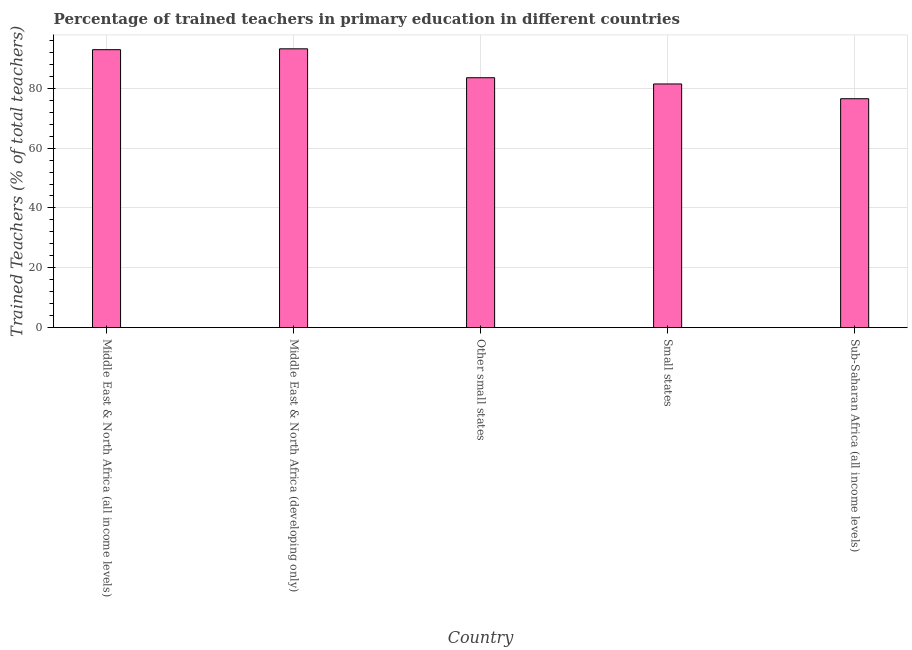Does the graph contain any zero values?
Your answer should be very brief. No. Does the graph contain grids?
Offer a very short reply. Yes. What is the title of the graph?
Make the answer very short. Percentage of trained teachers in primary education in different countries. What is the label or title of the X-axis?
Give a very brief answer. Country. What is the label or title of the Y-axis?
Provide a succinct answer. Trained Teachers (% of total teachers). What is the percentage of trained teachers in Middle East & North Africa (developing only)?
Your answer should be very brief. 93.18. Across all countries, what is the maximum percentage of trained teachers?
Provide a short and direct response. 93.18. Across all countries, what is the minimum percentage of trained teachers?
Your answer should be compact. 76.5. In which country was the percentage of trained teachers maximum?
Provide a short and direct response. Middle East & North Africa (developing only). In which country was the percentage of trained teachers minimum?
Provide a succinct answer. Sub-Saharan Africa (all income levels). What is the sum of the percentage of trained teachers?
Ensure brevity in your answer.  427.52. What is the difference between the percentage of trained teachers in Other small states and Sub-Saharan Africa (all income levels)?
Give a very brief answer. 7.02. What is the average percentage of trained teachers per country?
Keep it short and to the point. 85.5. What is the median percentage of trained teachers?
Provide a succinct answer. 83.52. What is the ratio of the percentage of trained teachers in Middle East & North Africa (all income levels) to that in Small states?
Offer a very short reply. 1.14. Is the percentage of trained teachers in Other small states less than that in Small states?
Offer a very short reply. No. Is the difference between the percentage of trained teachers in Other small states and Sub-Saharan Africa (all income levels) greater than the difference between any two countries?
Keep it short and to the point. No. What is the difference between the highest and the second highest percentage of trained teachers?
Your response must be concise. 0.29. What is the difference between the highest and the lowest percentage of trained teachers?
Give a very brief answer. 16.68. In how many countries, is the percentage of trained teachers greater than the average percentage of trained teachers taken over all countries?
Your answer should be very brief. 2. How many bars are there?
Offer a very short reply. 5. Are all the bars in the graph horizontal?
Ensure brevity in your answer.  No. What is the difference between two consecutive major ticks on the Y-axis?
Your response must be concise. 20. What is the Trained Teachers (% of total teachers) of Middle East & North Africa (all income levels)?
Your answer should be compact. 92.89. What is the Trained Teachers (% of total teachers) in Middle East & North Africa (developing only)?
Your answer should be very brief. 93.18. What is the Trained Teachers (% of total teachers) in Other small states?
Give a very brief answer. 83.52. What is the Trained Teachers (% of total teachers) in Small states?
Provide a succinct answer. 81.43. What is the Trained Teachers (% of total teachers) of Sub-Saharan Africa (all income levels)?
Offer a very short reply. 76.5. What is the difference between the Trained Teachers (% of total teachers) in Middle East & North Africa (all income levels) and Middle East & North Africa (developing only)?
Your answer should be compact. -0.29. What is the difference between the Trained Teachers (% of total teachers) in Middle East & North Africa (all income levels) and Other small states?
Offer a terse response. 9.38. What is the difference between the Trained Teachers (% of total teachers) in Middle East & North Africa (all income levels) and Small states?
Ensure brevity in your answer.  11.46. What is the difference between the Trained Teachers (% of total teachers) in Middle East & North Africa (all income levels) and Sub-Saharan Africa (all income levels)?
Provide a short and direct response. 16.39. What is the difference between the Trained Teachers (% of total teachers) in Middle East & North Africa (developing only) and Other small states?
Give a very brief answer. 9.66. What is the difference between the Trained Teachers (% of total teachers) in Middle East & North Africa (developing only) and Small states?
Give a very brief answer. 11.75. What is the difference between the Trained Teachers (% of total teachers) in Middle East & North Africa (developing only) and Sub-Saharan Africa (all income levels)?
Your response must be concise. 16.68. What is the difference between the Trained Teachers (% of total teachers) in Other small states and Small states?
Keep it short and to the point. 2.08. What is the difference between the Trained Teachers (% of total teachers) in Other small states and Sub-Saharan Africa (all income levels)?
Your response must be concise. 7.02. What is the difference between the Trained Teachers (% of total teachers) in Small states and Sub-Saharan Africa (all income levels)?
Give a very brief answer. 4.93. What is the ratio of the Trained Teachers (% of total teachers) in Middle East & North Africa (all income levels) to that in Other small states?
Offer a terse response. 1.11. What is the ratio of the Trained Teachers (% of total teachers) in Middle East & North Africa (all income levels) to that in Small states?
Make the answer very short. 1.14. What is the ratio of the Trained Teachers (% of total teachers) in Middle East & North Africa (all income levels) to that in Sub-Saharan Africa (all income levels)?
Your response must be concise. 1.21. What is the ratio of the Trained Teachers (% of total teachers) in Middle East & North Africa (developing only) to that in Other small states?
Your response must be concise. 1.12. What is the ratio of the Trained Teachers (% of total teachers) in Middle East & North Africa (developing only) to that in Small states?
Provide a short and direct response. 1.14. What is the ratio of the Trained Teachers (% of total teachers) in Middle East & North Africa (developing only) to that in Sub-Saharan Africa (all income levels)?
Ensure brevity in your answer.  1.22. What is the ratio of the Trained Teachers (% of total teachers) in Other small states to that in Sub-Saharan Africa (all income levels)?
Your answer should be compact. 1.09. What is the ratio of the Trained Teachers (% of total teachers) in Small states to that in Sub-Saharan Africa (all income levels)?
Give a very brief answer. 1.06. 